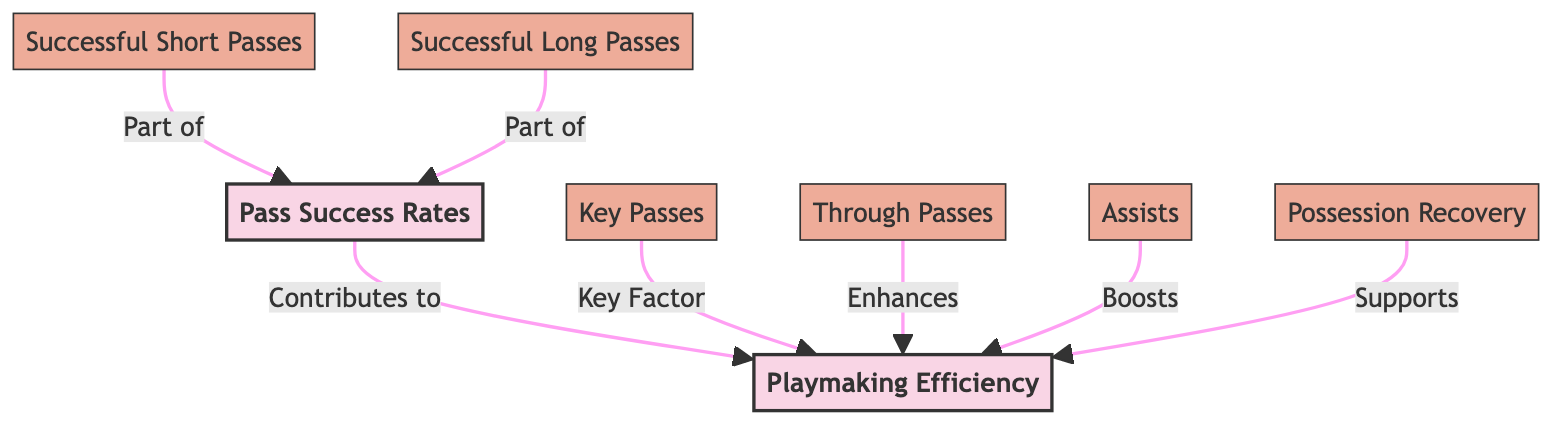What are the two main nodes in the diagram? The main nodes in the diagram are "Pass Success Rates" and "Playmaking Efficiency," which are indicated as the two top-level concepts in the flowchart.
Answer: Pass Success Rates, Playmaking Efficiency Which node contributes to Playmaking Efficiency? The node "Pass Success Rates" is depicted as contributing to "Playmaking Efficiency," showing a direct link and relationship between them in the diagram.
Answer: Pass Success Rates How many sub-nodes are there under Pass Success Rates? The diagram shows two sub-nodes branching from "Pass Success Rates," which are "Successful Short Passes" and "Successful Long Passes." Counting these nodes gives the total.
Answer: 2 What is a key factor of Playmaking Efficiency? The node "Key Passes" is labeled as a key factor contributing to "Playmaking Efficiency," indicating its importance in the overall playmaking evaluation in the diagram.
Answer: Key Passes Which node enhances Playmaking Efficiency? The diagram specifies that "Through Passes" enhances "Playmaking Efficiency," highlighting its functional role in improving playmaking outcomes.
Answer: Through Passes How many total edges are present in the diagram? By counting each directed connection shown in the diagram, we note there are seven edges that relate the nodes, indicating the relationships among pass success and playmaking elements.
Answer: 7 What supports Playmaking Efficiency? The node "Possession Recovery" is indicated as supporting "Playmaking Efficiency," demonstrating its role in contributing to effective playmaking through regained possession.
Answer: Possession Recovery What relationship exists between Successful Short Passes and Pass Success Rates? The relationship depicted shows that "Successful Short Passes" is part of "Pass Success Rates," indicating that successful short passes contribute to the overall assessment of passing success.
Answer: Part of Which element is boosted by Assists? The node "Assists" is associated with boosting "Playmaking Efficiency," indicating that achieving assists in play contributes positively to the overall efficiency in playmaking evaluated in the diagram.
Answer: Playmaking Efficiency 